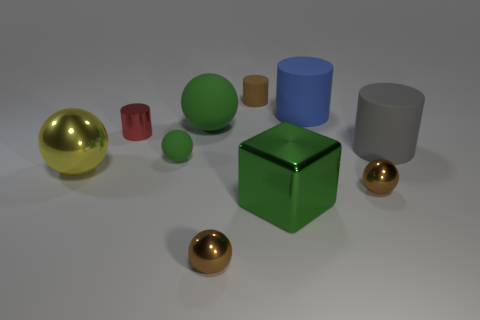There is a big shiny thing right of the big yellow sphere; is it the same color as the big matte ball?
Provide a succinct answer. Yes. There is a rubber object that is the same color as the big rubber sphere; what size is it?
Your answer should be compact. Small. Is there a green object that has the same size as the red metal thing?
Make the answer very short. Yes. The other tiny object that is the same shape as the red metal object is what color?
Ensure brevity in your answer.  Brown. There is a big green thing that is to the left of the tiny brown matte object; are there any green rubber spheres in front of it?
Provide a succinct answer. Yes. Is the shape of the brown thing that is behind the shiny cylinder the same as  the big gray rubber thing?
Give a very brief answer. Yes. There is a blue matte thing; what shape is it?
Offer a very short reply. Cylinder. What number of small brown objects have the same material as the large green cube?
Keep it short and to the point. 2. Does the small rubber ball have the same color as the large matte object left of the brown cylinder?
Offer a terse response. Yes. What number of small metallic cylinders are there?
Keep it short and to the point. 1. 